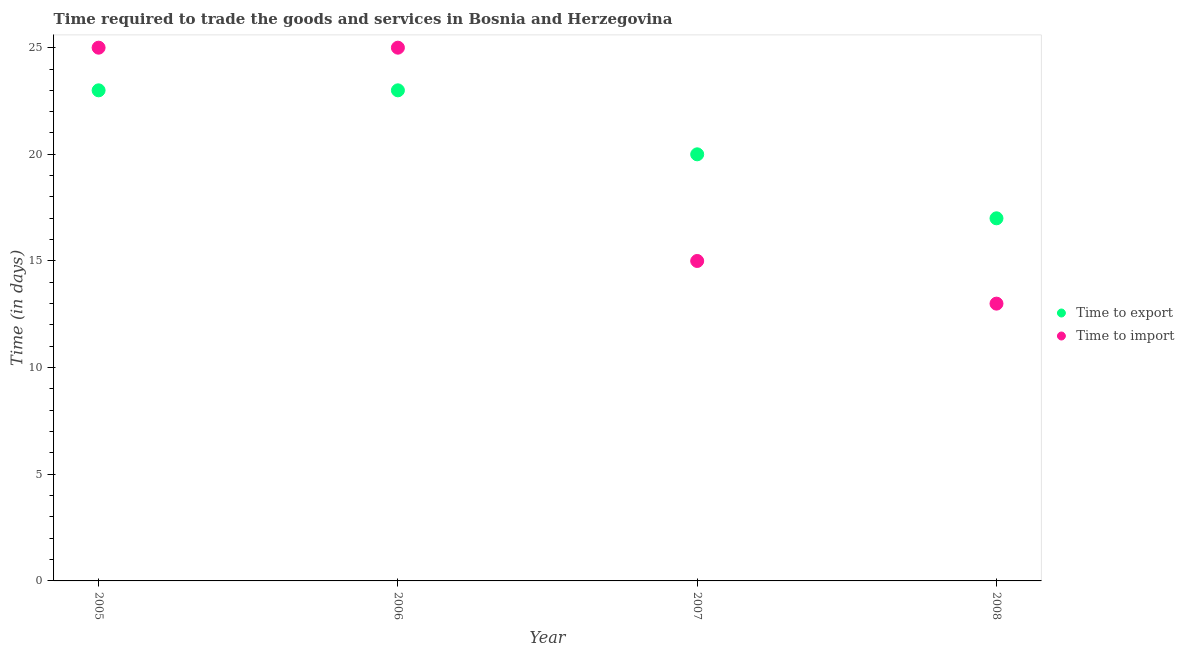What is the time to export in 2006?
Provide a short and direct response. 23. Across all years, what is the maximum time to export?
Your response must be concise. 23. Across all years, what is the minimum time to import?
Offer a terse response. 13. In which year was the time to export maximum?
Provide a short and direct response. 2005. In which year was the time to import minimum?
Your answer should be compact. 2008. What is the total time to import in the graph?
Offer a terse response. 78. What is the difference between the time to import in 2006 and that in 2007?
Offer a very short reply. 10. What is the difference between the time to export in 2006 and the time to import in 2005?
Offer a terse response. -2. In the year 2006, what is the difference between the time to import and time to export?
Keep it short and to the point. 2. What is the ratio of the time to export in 2006 to that in 2007?
Provide a succinct answer. 1.15. Is the time to import in 2005 less than that in 2008?
Ensure brevity in your answer.  No. Is the difference between the time to export in 2005 and 2006 greater than the difference between the time to import in 2005 and 2006?
Make the answer very short. No. What is the difference between the highest and the second highest time to export?
Provide a succinct answer. 0. What is the difference between the highest and the lowest time to import?
Provide a succinct answer. 12. Does the time to import monotonically increase over the years?
Your answer should be compact. No. Is the time to import strictly less than the time to export over the years?
Keep it short and to the point. No. How many dotlines are there?
Your answer should be compact. 2. How many years are there in the graph?
Give a very brief answer. 4. What is the difference between two consecutive major ticks on the Y-axis?
Offer a terse response. 5. Does the graph contain any zero values?
Offer a terse response. No. How many legend labels are there?
Your response must be concise. 2. What is the title of the graph?
Give a very brief answer. Time required to trade the goods and services in Bosnia and Herzegovina. What is the label or title of the Y-axis?
Your answer should be very brief. Time (in days). What is the Time (in days) of Time to import in 2005?
Provide a short and direct response. 25. What is the Time (in days) in Time to import in 2006?
Offer a very short reply. 25. What is the Time (in days) in Time to import in 2007?
Ensure brevity in your answer.  15. What is the Time (in days) of Time to import in 2008?
Provide a short and direct response. 13. Across all years, what is the maximum Time (in days) of Time to import?
Offer a very short reply. 25. Across all years, what is the minimum Time (in days) of Time to export?
Offer a very short reply. 17. Across all years, what is the minimum Time (in days) in Time to import?
Provide a short and direct response. 13. What is the total Time (in days) of Time to export in the graph?
Ensure brevity in your answer.  83. What is the difference between the Time (in days) of Time to export in 2005 and that in 2006?
Your answer should be very brief. 0. What is the difference between the Time (in days) in Time to export in 2005 and that in 2007?
Give a very brief answer. 3. What is the difference between the Time (in days) in Time to import in 2006 and that in 2008?
Your answer should be very brief. 12. What is the difference between the Time (in days) in Time to export in 2007 and that in 2008?
Your answer should be compact. 3. What is the difference between the Time (in days) of Time to import in 2007 and that in 2008?
Offer a very short reply. 2. What is the average Time (in days) of Time to export per year?
Your response must be concise. 20.75. In the year 2005, what is the difference between the Time (in days) of Time to export and Time (in days) of Time to import?
Your answer should be compact. -2. In the year 2006, what is the difference between the Time (in days) of Time to export and Time (in days) of Time to import?
Your answer should be compact. -2. In the year 2007, what is the difference between the Time (in days) in Time to export and Time (in days) in Time to import?
Your answer should be very brief. 5. In the year 2008, what is the difference between the Time (in days) of Time to export and Time (in days) of Time to import?
Your answer should be very brief. 4. What is the ratio of the Time (in days) in Time to export in 2005 to that in 2007?
Your response must be concise. 1.15. What is the ratio of the Time (in days) in Time to export in 2005 to that in 2008?
Provide a short and direct response. 1.35. What is the ratio of the Time (in days) in Time to import in 2005 to that in 2008?
Your answer should be very brief. 1.92. What is the ratio of the Time (in days) of Time to export in 2006 to that in 2007?
Make the answer very short. 1.15. What is the ratio of the Time (in days) of Time to import in 2006 to that in 2007?
Ensure brevity in your answer.  1.67. What is the ratio of the Time (in days) of Time to export in 2006 to that in 2008?
Offer a terse response. 1.35. What is the ratio of the Time (in days) of Time to import in 2006 to that in 2008?
Make the answer very short. 1.92. What is the ratio of the Time (in days) in Time to export in 2007 to that in 2008?
Keep it short and to the point. 1.18. What is the ratio of the Time (in days) of Time to import in 2007 to that in 2008?
Ensure brevity in your answer.  1.15. What is the difference between the highest and the second highest Time (in days) in Time to export?
Your answer should be very brief. 0. What is the difference between the highest and the second highest Time (in days) of Time to import?
Make the answer very short. 0. 